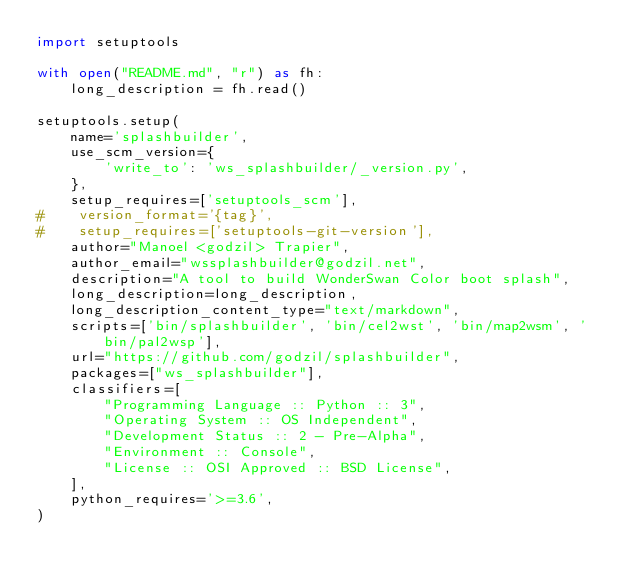<code> <loc_0><loc_0><loc_500><loc_500><_Python_>import setuptools

with open("README.md", "r") as fh:
    long_description = fh.read()

setuptools.setup(
    name='splashbuilder',
    use_scm_version={
        'write_to': 'ws_splashbuilder/_version.py',
    },
    setup_requires=['setuptools_scm'],
#    version_format='{tag}',
#    setup_requires=['setuptools-git-version'],
    author="Manoel <godzil> Trapier",
    author_email="wssplashbuilder@godzil.net",
    description="A tool to build WonderSwan Color boot splash",
    long_description=long_description,
    long_description_content_type="text/markdown",
    scripts=['bin/splashbuilder', 'bin/cel2wst', 'bin/map2wsm', 'bin/pal2wsp'],
    url="https://github.com/godzil/splashbuilder",
    packages=["ws_splashbuilder"],
    classifiers=[
        "Programming Language :: Python :: 3",
        "Operating System :: OS Independent",
        "Development Status :: 2 - Pre-Alpha",
        "Environment :: Console",
        "License :: OSI Approved :: BSD License",
    ],
    python_requires='>=3.6',
)
</code> 